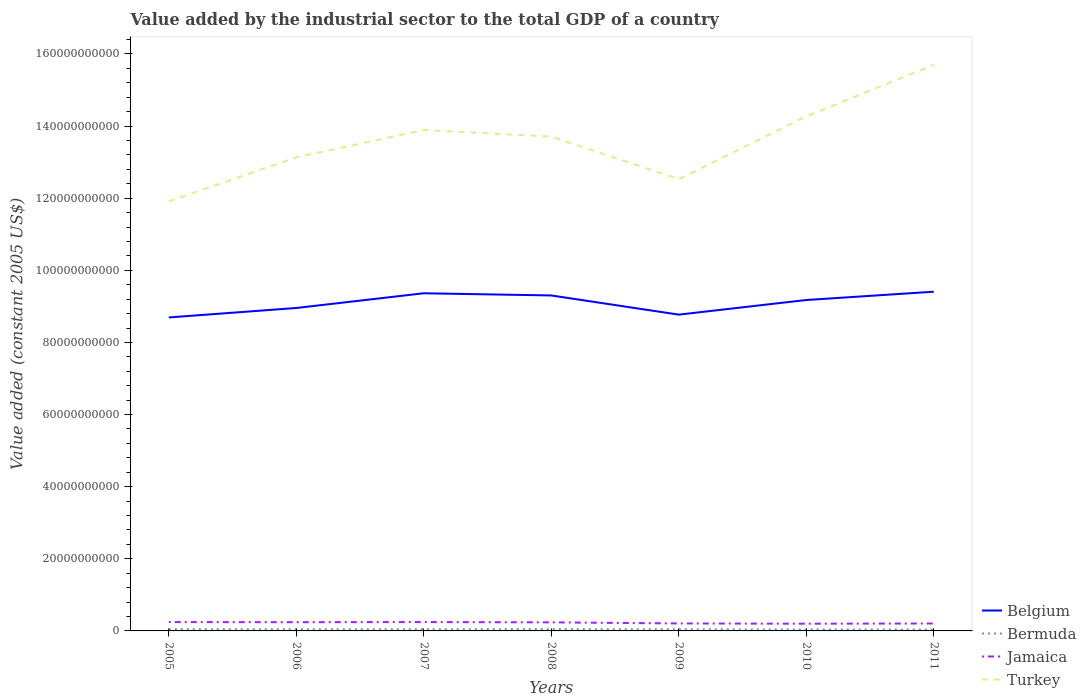How many different coloured lines are there?
Offer a terse response. 4. Does the line corresponding to Bermuda intersect with the line corresponding to Turkey?
Offer a very short reply. No. Across all years, what is the maximum value added by the industrial sector in Belgium?
Your answer should be very brief. 8.69e+1. In which year was the value added by the industrial sector in Turkey maximum?
Your answer should be very brief. 2005. What is the total value added by the industrial sector in Jamaica in the graph?
Your response must be concise. 4.50e+08. What is the difference between the highest and the second highest value added by the industrial sector in Belgium?
Ensure brevity in your answer.  7.14e+09. What is the difference between the highest and the lowest value added by the industrial sector in Jamaica?
Keep it short and to the point. 4. How many lines are there?
Give a very brief answer. 4. How many years are there in the graph?
Keep it short and to the point. 7. What is the difference between two consecutive major ticks on the Y-axis?
Make the answer very short. 2.00e+1. Does the graph contain grids?
Give a very brief answer. No. Where does the legend appear in the graph?
Your answer should be compact. Bottom right. How are the legend labels stacked?
Your response must be concise. Vertical. What is the title of the graph?
Provide a succinct answer. Value added by the industrial sector to the total GDP of a country. What is the label or title of the Y-axis?
Your answer should be compact. Value added (constant 2005 US$). What is the Value added (constant 2005 US$) in Belgium in 2005?
Offer a very short reply. 8.69e+1. What is the Value added (constant 2005 US$) of Bermuda in 2005?
Offer a terse response. 4.84e+08. What is the Value added (constant 2005 US$) of Jamaica in 2005?
Make the answer very short. 2.45e+09. What is the Value added (constant 2005 US$) in Turkey in 2005?
Ensure brevity in your answer.  1.19e+11. What is the Value added (constant 2005 US$) in Belgium in 2006?
Offer a very short reply. 8.96e+1. What is the Value added (constant 2005 US$) of Bermuda in 2006?
Give a very brief answer. 4.71e+08. What is the Value added (constant 2005 US$) in Jamaica in 2006?
Your response must be concise. 2.42e+09. What is the Value added (constant 2005 US$) in Turkey in 2006?
Make the answer very short. 1.31e+11. What is the Value added (constant 2005 US$) in Belgium in 2007?
Keep it short and to the point. 9.36e+1. What is the Value added (constant 2005 US$) of Bermuda in 2007?
Give a very brief answer. 4.71e+08. What is the Value added (constant 2005 US$) in Jamaica in 2007?
Make the answer very short. 2.46e+09. What is the Value added (constant 2005 US$) in Turkey in 2007?
Your response must be concise. 1.39e+11. What is the Value added (constant 2005 US$) of Belgium in 2008?
Keep it short and to the point. 9.30e+1. What is the Value added (constant 2005 US$) of Bermuda in 2008?
Offer a very short reply. 4.96e+08. What is the Value added (constant 2005 US$) in Jamaica in 2008?
Keep it short and to the point. 2.38e+09. What is the Value added (constant 2005 US$) of Turkey in 2008?
Your answer should be compact. 1.37e+11. What is the Value added (constant 2005 US$) of Belgium in 2009?
Your response must be concise. 8.77e+1. What is the Value added (constant 2005 US$) of Bermuda in 2009?
Offer a terse response. 4.49e+08. What is the Value added (constant 2005 US$) in Jamaica in 2009?
Your response must be concise. 2.07e+09. What is the Value added (constant 2005 US$) in Turkey in 2009?
Provide a succinct answer. 1.25e+11. What is the Value added (constant 2005 US$) of Belgium in 2010?
Make the answer very short. 9.18e+1. What is the Value added (constant 2005 US$) in Bermuda in 2010?
Keep it short and to the point. 3.98e+08. What is the Value added (constant 2005 US$) of Jamaica in 2010?
Offer a terse response. 2.00e+09. What is the Value added (constant 2005 US$) in Turkey in 2010?
Your answer should be compact. 1.43e+11. What is the Value added (constant 2005 US$) in Belgium in 2011?
Your answer should be compact. 9.41e+1. What is the Value added (constant 2005 US$) of Bermuda in 2011?
Provide a short and direct response. 3.90e+08. What is the Value added (constant 2005 US$) in Jamaica in 2011?
Offer a terse response. 2.06e+09. What is the Value added (constant 2005 US$) of Turkey in 2011?
Make the answer very short. 1.57e+11. Across all years, what is the maximum Value added (constant 2005 US$) of Belgium?
Make the answer very short. 9.41e+1. Across all years, what is the maximum Value added (constant 2005 US$) in Bermuda?
Provide a succinct answer. 4.96e+08. Across all years, what is the maximum Value added (constant 2005 US$) in Jamaica?
Give a very brief answer. 2.46e+09. Across all years, what is the maximum Value added (constant 2005 US$) of Turkey?
Provide a succinct answer. 1.57e+11. Across all years, what is the minimum Value added (constant 2005 US$) of Belgium?
Provide a succinct answer. 8.69e+1. Across all years, what is the minimum Value added (constant 2005 US$) of Bermuda?
Ensure brevity in your answer.  3.90e+08. Across all years, what is the minimum Value added (constant 2005 US$) in Jamaica?
Give a very brief answer. 2.00e+09. Across all years, what is the minimum Value added (constant 2005 US$) in Turkey?
Give a very brief answer. 1.19e+11. What is the total Value added (constant 2005 US$) in Belgium in the graph?
Offer a terse response. 6.37e+11. What is the total Value added (constant 2005 US$) in Bermuda in the graph?
Make the answer very short. 3.16e+09. What is the total Value added (constant 2005 US$) in Jamaica in the graph?
Your answer should be compact. 1.59e+1. What is the total Value added (constant 2005 US$) in Turkey in the graph?
Your response must be concise. 9.51e+11. What is the difference between the Value added (constant 2005 US$) in Belgium in 2005 and that in 2006?
Ensure brevity in your answer.  -2.62e+09. What is the difference between the Value added (constant 2005 US$) of Bermuda in 2005 and that in 2006?
Provide a short and direct response. 1.34e+07. What is the difference between the Value added (constant 2005 US$) in Jamaica in 2005 and that in 2006?
Ensure brevity in your answer.  3.22e+07. What is the difference between the Value added (constant 2005 US$) in Turkey in 2005 and that in 2006?
Offer a terse response. -1.22e+1. What is the difference between the Value added (constant 2005 US$) of Belgium in 2005 and that in 2007?
Make the answer very short. -6.70e+09. What is the difference between the Value added (constant 2005 US$) in Bermuda in 2005 and that in 2007?
Make the answer very short. 1.31e+07. What is the difference between the Value added (constant 2005 US$) in Jamaica in 2005 and that in 2007?
Give a very brief answer. -4.26e+06. What is the difference between the Value added (constant 2005 US$) in Turkey in 2005 and that in 2007?
Keep it short and to the point. -1.98e+1. What is the difference between the Value added (constant 2005 US$) in Belgium in 2005 and that in 2008?
Your answer should be compact. -6.09e+09. What is the difference between the Value added (constant 2005 US$) in Bermuda in 2005 and that in 2008?
Offer a terse response. -1.13e+07. What is the difference between the Value added (constant 2005 US$) of Jamaica in 2005 and that in 2008?
Make the answer very short. 7.34e+07. What is the difference between the Value added (constant 2005 US$) of Turkey in 2005 and that in 2008?
Give a very brief answer. -1.80e+1. What is the difference between the Value added (constant 2005 US$) in Belgium in 2005 and that in 2009?
Provide a short and direct response. -7.76e+08. What is the difference between the Value added (constant 2005 US$) in Bermuda in 2005 and that in 2009?
Provide a short and direct response. 3.53e+07. What is the difference between the Value added (constant 2005 US$) of Jamaica in 2005 and that in 2009?
Offer a terse response. 3.81e+08. What is the difference between the Value added (constant 2005 US$) of Turkey in 2005 and that in 2009?
Make the answer very short. -6.16e+09. What is the difference between the Value added (constant 2005 US$) of Belgium in 2005 and that in 2010?
Your response must be concise. -4.83e+09. What is the difference between the Value added (constant 2005 US$) of Bermuda in 2005 and that in 2010?
Offer a terse response. 8.69e+07. What is the difference between the Value added (constant 2005 US$) of Jamaica in 2005 and that in 2010?
Your answer should be compact. 4.50e+08. What is the difference between the Value added (constant 2005 US$) in Turkey in 2005 and that in 2010?
Offer a terse response. -2.35e+1. What is the difference between the Value added (constant 2005 US$) of Belgium in 2005 and that in 2011?
Your response must be concise. -7.14e+09. What is the difference between the Value added (constant 2005 US$) in Bermuda in 2005 and that in 2011?
Provide a short and direct response. 9.45e+07. What is the difference between the Value added (constant 2005 US$) in Jamaica in 2005 and that in 2011?
Give a very brief answer. 3.92e+08. What is the difference between the Value added (constant 2005 US$) in Turkey in 2005 and that in 2011?
Give a very brief answer. -3.79e+1. What is the difference between the Value added (constant 2005 US$) in Belgium in 2006 and that in 2007?
Your response must be concise. -4.08e+09. What is the difference between the Value added (constant 2005 US$) in Bermuda in 2006 and that in 2007?
Give a very brief answer. -2.84e+05. What is the difference between the Value added (constant 2005 US$) in Jamaica in 2006 and that in 2007?
Offer a terse response. -3.65e+07. What is the difference between the Value added (constant 2005 US$) of Turkey in 2006 and that in 2007?
Your response must be concise. -7.57e+09. What is the difference between the Value added (constant 2005 US$) of Belgium in 2006 and that in 2008?
Give a very brief answer. -3.47e+09. What is the difference between the Value added (constant 2005 US$) in Bermuda in 2006 and that in 2008?
Ensure brevity in your answer.  -2.48e+07. What is the difference between the Value added (constant 2005 US$) in Jamaica in 2006 and that in 2008?
Make the answer very short. 4.12e+07. What is the difference between the Value added (constant 2005 US$) in Turkey in 2006 and that in 2008?
Provide a short and direct response. -5.76e+09. What is the difference between the Value added (constant 2005 US$) in Belgium in 2006 and that in 2009?
Provide a succinct answer. 1.84e+09. What is the difference between the Value added (constant 2005 US$) of Bermuda in 2006 and that in 2009?
Your answer should be compact. 2.19e+07. What is the difference between the Value added (constant 2005 US$) in Jamaica in 2006 and that in 2009?
Offer a terse response. 3.49e+08. What is the difference between the Value added (constant 2005 US$) of Turkey in 2006 and that in 2009?
Make the answer very short. 6.04e+09. What is the difference between the Value added (constant 2005 US$) of Belgium in 2006 and that in 2010?
Give a very brief answer. -2.21e+09. What is the difference between the Value added (constant 2005 US$) in Bermuda in 2006 and that in 2010?
Keep it short and to the point. 7.35e+07. What is the difference between the Value added (constant 2005 US$) of Jamaica in 2006 and that in 2010?
Give a very brief answer. 4.17e+08. What is the difference between the Value added (constant 2005 US$) in Turkey in 2006 and that in 2010?
Give a very brief answer. -1.14e+1. What is the difference between the Value added (constant 2005 US$) of Belgium in 2006 and that in 2011?
Provide a succinct answer. -4.51e+09. What is the difference between the Value added (constant 2005 US$) in Bermuda in 2006 and that in 2011?
Make the answer very short. 8.11e+07. What is the difference between the Value added (constant 2005 US$) of Jamaica in 2006 and that in 2011?
Keep it short and to the point. 3.59e+08. What is the difference between the Value added (constant 2005 US$) in Turkey in 2006 and that in 2011?
Ensure brevity in your answer.  -2.57e+1. What is the difference between the Value added (constant 2005 US$) of Belgium in 2007 and that in 2008?
Your answer should be compact. 6.09e+08. What is the difference between the Value added (constant 2005 US$) of Bermuda in 2007 and that in 2008?
Your response must be concise. -2.45e+07. What is the difference between the Value added (constant 2005 US$) in Jamaica in 2007 and that in 2008?
Keep it short and to the point. 7.76e+07. What is the difference between the Value added (constant 2005 US$) of Turkey in 2007 and that in 2008?
Make the answer very short. 1.81e+09. What is the difference between the Value added (constant 2005 US$) of Belgium in 2007 and that in 2009?
Ensure brevity in your answer.  5.93e+09. What is the difference between the Value added (constant 2005 US$) of Bermuda in 2007 and that in 2009?
Give a very brief answer. 2.22e+07. What is the difference between the Value added (constant 2005 US$) in Jamaica in 2007 and that in 2009?
Ensure brevity in your answer.  3.86e+08. What is the difference between the Value added (constant 2005 US$) in Turkey in 2007 and that in 2009?
Ensure brevity in your answer.  1.36e+1. What is the difference between the Value added (constant 2005 US$) of Belgium in 2007 and that in 2010?
Your answer should be compact. 1.87e+09. What is the difference between the Value added (constant 2005 US$) in Bermuda in 2007 and that in 2010?
Offer a very short reply. 7.38e+07. What is the difference between the Value added (constant 2005 US$) in Jamaica in 2007 and that in 2010?
Your answer should be compact. 4.54e+08. What is the difference between the Value added (constant 2005 US$) of Turkey in 2007 and that in 2010?
Give a very brief answer. -3.78e+09. What is the difference between the Value added (constant 2005 US$) in Belgium in 2007 and that in 2011?
Give a very brief answer. -4.31e+08. What is the difference between the Value added (constant 2005 US$) in Bermuda in 2007 and that in 2011?
Offer a very short reply. 8.14e+07. What is the difference between the Value added (constant 2005 US$) in Jamaica in 2007 and that in 2011?
Give a very brief answer. 3.96e+08. What is the difference between the Value added (constant 2005 US$) in Turkey in 2007 and that in 2011?
Your response must be concise. -1.81e+1. What is the difference between the Value added (constant 2005 US$) in Belgium in 2008 and that in 2009?
Your response must be concise. 5.32e+09. What is the difference between the Value added (constant 2005 US$) of Bermuda in 2008 and that in 2009?
Ensure brevity in your answer.  4.66e+07. What is the difference between the Value added (constant 2005 US$) in Jamaica in 2008 and that in 2009?
Ensure brevity in your answer.  3.08e+08. What is the difference between the Value added (constant 2005 US$) in Turkey in 2008 and that in 2009?
Keep it short and to the point. 1.18e+1. What is the difference between the Value added (constant 2005 US$) of Belgium in 2008 and that in 2010?
Your answer should be compact. 1.26e+09. What is the difference between the Value added (constant 2005 US$) in Bermuda in 2008 and that in 2010?
Your response must be concise. 9.82e+07. What is the difference between the Value added (constant 2005 US$) of Jamaica in 2008 and that in 2010?
Your answer should be compact. 3.76e+08. What is the difference between the Value added (constant 2005 US$) in Turkey in 2008 and that in 2010?
Your answer should be compact. -5.60e+09. What is the difference between the Value added (constant 2005 US$) of Belgium in 2008 and that in 2011?
Offer a terse response. -1.04e+09. What is the difference between the Value added (constant 2005 US$) in Bermuda in 2008 and that in 2011?
Provide a succinct answer. 1.06e+08. What is the difference between the Value added (constant 2005 US$) of Jamaica in 2008 and that in 2011?
Offer a terse response. 3.18e+08. What is the difference between the Value added (constant 2005 US$) of Turkey in 2008 and that in 2011?
Provide a short and direct response. -1.99e+1. What is the difference between the Value added (constant 2005 US$) in Belgium in 2009 and that in 2010?
Your answer should be compact. -4.05e+09. What is the difference between the Value added (constant 2005 US$) of Bermuda in 2009 and that in 2010?
Your answer should be very brief. 5.16e+07. What is the difference between the Value added (constant 2005 US$) of Jamaica in 2009 and that in 2010?
Provide a succinct answer. 6.83e+07. What is the difference between the Value added (constant 2005 US$) of Turkey in 2009 and that in 2010?
Offer a very short reply. -1.74e+1. What is the difference between the Value added (constant 2005 US$) of Belgium in 2009 and that in 2011?
Keep it short and to the point. -6.36e+09. What is the difference between the Value added (constant 2005 US$) in Bermuda in 2009 and that in 2011?
Offer a very short reply. 5.92e+07. What is the difference between the Value added (constant 2005 US$) of Jamaica in 2009 and that in 2011?
Provide a short and direct response. 1.03e+07. What is the difference between the Value added (constant 2005 US$) of Turkey in 2009 and that in 2011?
Give a very brief answer. -3.17e+1. What is the difference between the Value added (constant 2005 US$) of Belgium in 2010 and that in 2011?
Your answer should be very brief. -2.30e+09. What is the difference between the Value added (constant 2005 US$) of Bermuda in 2010 and that in 2011?
Your answer should be very brief. 7.61e+06. What is the difference between the Value added (constant 2005 US$) of Jamaica in 2010 and that in 2011?
Keep it short and to the point. -5.79e+07. What is the difference between the Value added (constant 2005 US$) in Turkey in 2010 and that in 2011?
Offer a terse response. -1.43e+1. What is the difference between the Value added (constant 2005 US$) in Belgium in 2005 and the Value added (constant 2005 US$) in Bermuda in 2006?
Provide a succinct answer. 8.65e+1. What is the difference between the Value added (constant 2005 US$) of Belgium in 2005 and the Value added (constant 2005 US$) of Jamaica in 2006?
Your response must be concise. 8.45e+1. What is the difference between the Value added (constant 2005 US$) of Belgium in 2005 and the Value added (constant 2005 US$) of Turkey in 2006?
Offer a very short reply. -4.44e+1. What is the difference between the Value added (constant 2005 US$) in Bermuda in 2005 and the Value added (constant 2005 US$) in Jamaica in 2006?
Offer a terse response. -1.94e+09. What is the difference between the Value added (constant 2005 US$) of Bermuda in 2005 and the Value added (constant 2005 US$) of Turkey in 2006?
Ensure brevity in your answer.  -1.31e+11. What is the difference between the Value added (constant 2005 US$) of Jamaica in 2005 and the Value added (constant 2005 US$) of Turkey in 2006?
Ensure brevity in your answer.  -1.29e+11. What is the difference between the Value added (constant 2005 US$) of Belgium in 2005 and the Value added (constant 2005 US$) of Bermuda in 2007?
Offer a terse response. 8.65e+1. What is the difference between the Value added (constant 2005 US$) of Belgium in 2005 and the Value added (constant 2005 US$) of Jamaica in 2007?
Provide a succinct answer. 8.45e+1. What is the difference between the Value added (constant 2005 US$) in Belgium in 2005 and the Value added (constant 2005 US$) in Turkey in 2007?
Offer a very short reply. -5.20e+1. What is the difference between the Value added (constant 2005 US$) of Bermuda in 2005 and the Value added (constant 2005 US$) of Jamaica in 2007?
Offer a very short reply. -1.97e+09. What is the difference between the Value added (constant 2005 US$) of Bermuda in 2005 and the Value added (constant 2005 US$) of Turkey in 2007?
Your answer should be very brief. -1.38e+11. What is the difference between the Value added (constant 2005 US$) in Jamaica in 2005 and the Value added (constant 2005 US$) in Turkey in 2007?
Offer a terse response. -1.36e+11. What is the difference between the Value added (constant 2005 US$) of Belgium in 2005 and the Value added (constant 2005 US$) of Bermuda in 2008?
Give a very brief answer. 8.64e+1. What is the difference between the Value added (constant 2005 US$) in Belgium in 2005 and the Value added (constant 2005 US$) in Jamaica in 2008?
Provide a succinct answer. 8.46e+1. What is the difference between the Value added (constant 2005 US$) in Belgium in 2005 and the Value added (constant 2005 US$) in Turkey in 2008?
Offer a terse response. -5.02e+1. What is the difference between the Value added (constant 2005 US$) of Bermuda in 2005 and the Value added (constant 2005 US$) of Jamaica in 2008?
Your response must be concise. -1.90e+09. What is the difference between the Value added (constant 2005 US$) in Bermuda in 2005 and the Value added (constant 2005 US$) in Turkey in 2008?
Give a very brief answer. -1.37e+11. What is the difference between the Value added (constant 2005 US$) in Jamaica in 2005 and the Value added (constant 2005 US$) in Turkey in 2008?
Make the answer very short. -1.35e+11. What is the difference between the Value added (constant 2005 US$) in Belgium in 2005 and the Value added (constant 2005 US$) in Bermuda in 2009?
Your response must be concise. 8.65e+1. What is the difference between the Value added (constant 2005 US$) in Belgium in 2005 and the Value added (constant 2005 US$) in Jamaica in 2009?
Your answer should be very brief. 8.49e+1. What is the difference between the Value added (constant 2005 US$) of Belgium in 2005 and the Value added (constant 2005 US$) of Turkey in 2009?
Ensure brevity in your answer.  -3.84e+1. What is the difference between the Value added (constant 2005 US$) in Bermuda in 2005 and the Value added (constant 2005 US$) in Jamaica in 2009?
Keep it short and to the point. -1.59e+09. What is the difference between the Value added (constant 2005 US$) in Bermuda in 2005 and the Value added (constant 2005 US$) in Turkey in 2009?
Your answer should be compact. -1.25e+11. What is the difference between the Value added (constant 2005 US$) of Jamaica in 2005 and the Value added (constant 2005 US$) of Turkey in 2009?
Offer a very short reply. -1.23e+11. What is the difference between the Value added (constant 2005 US$) of Belgium in 2005 and the Value added (constant 2005 US$) of Bermuda in 2010?
Your answer should be very brief. 8.65e+1. What is the difference between the Value added (constant 2005 US$) in Belgium in 2005 and the Value added (constant 2005 US$) in Jamaica in 2010?
Keep it short and to the point. 8.49e+1. What is the difference between the Value added (constant 2005 US$) of Belgium in 2005 and the Value added (constant 2005 US$) of Turkey in 2010?
Provide a succinct answer. -5.57e+1. What is the difference between the Value added (constant 2005 US$) in Bermuda in 2005 and the Value added (constant 2005 US$) in Jamaica in 2010?
Offer a terse response. -1.52e+09. What is the difference between the Value added (constant 2005 US$) in Bermuda in 2005 and the Value added (constant 2005 US$) in Turkey in 2010?
Your response must be concise. -1.42e+11. What is the difference between the Value added (constant 2005 US$) of Jamaica in 2005 and the Value added (constant 2005 US$) of Turkey in 2010?
Provide a short and direct response. -1.40e+11. What is the difference between the Value added (constant 2005 US$) in Belgium in 2005 and the Value added (constant 2005 US$) in Bermuda in 2011?
Your answer should be compact. 8.65e+1. What is the difference between the Value added (constant 2005 US$) of Belgium in 2005 and the Value added (constant 2005 US$) of Jamaica in 2011?
Ensure brevity in your answer.  8.49e+1. What is the difference between the Value added (constant 2005 US$) of Belgium in 2005 and the Value added (constant 2005 US$) of Turkey in 2011?
Offer a very short reply. -7.01e+1. What is the difference between the Value added (constant 2005 US$) of Bermuda in 2005 and the Value added (constant 2005 US$) of Jamaica in 2011?
Your answer should be very brief. -1.58e+09. What is the difference between the Value added (constant 2005 US$) in Bermuda in 2005 and the Value added (constant 2005 US$) in Turkey in 2011?
Provide a succinct answer. -1.57e+11. What is the difference between the Value added (constant 2005 US$) of Jamaica in 2005 and the Value added (constant 2005 US$) of Turkey in 2011?
Keep it short and to the point. -1.55e+11. What is the difference between the Value added (constant 2005 US$) of Belgium in 2006 and the Value added (constant 2005 US$) of Bermuda in 2007?
Ensure brevity in your answer.  8.91e+1. What is the difference between the Value added (constant 2005 US$) of Belgium in 2006 and the Value added (constant 2005 US$) of Jamaica in 2007?
Provide a succinct answer. 8.71e+1. What is the difference between the Value added (constant 2005 US$) in Belgium in 2006 and the Value added (constant 2005 US$) in Turkey in 2007?
Offer a terse response. -4.93e+1. What is the difference between the Value added (constant 2005 US$) in Bermuda in 2006 and the Value added (constant 2005 US$) in Jamaica in 2007?
Ensure brevity in your answer.  -1.99e+09. What is the difference between the Value added (constant 2005 US$) in Bermuda in 2006 and the Value added (constant 2005 US$) in Turkey in 2007?
Keep it short and to the point. -1.38e+11. What is the difference between the Value added (constant 2005 US$) of Jamaica in 2006 and the Value added (constant 2005 US$) of Turkey in 2007?
Your answer should be compact. -1.36e+11. What is the difference between the Value added (constant 2005 US$) in Belgium in 2006 and the Value added (constant 2005 US$) in Bermuda in 2008?
Your response must be concise. 8.91e+1. What is the difference between the Value added (constant 2005 US$) in Belgium in 2006 and the Value added (constant 2005 US$) in Jamaica in 2008?
Your answer should be compact. 8.72e+1. What is the difference between the Value added (constant 2005 US$) in Belgium in 2006 and the Value added (constant 2005 US$) in Turkey in 2008?
Provide a succinct answer. -4.75e+1. What is the difference between the Value added (constant 2005 US$) in Bermuda in 2006 and the Value added (constant 2005 US$) in Jamaica in 2008?
Your response must be concise. -1.91e+09. What is the difference between the Value added (constant 2005 US$) of Bermuda in 2006 and the Value added (constant 2005 US$) of Turkey in 2008?
Give a very brief answer. -1.37e+11. What is the difference between the Value added (constant 2005 US$) of Jamaica in 2006 and the Value added (constant 2005 US$) of Turkey in 2008?
Offer a terse response. -1.35e+11. What is the difference between the Value added (constant 2005 US$) of Belgium in 2006 and the Value added (constant 2005 US$) of Bermuda in 2009?
Your answer should be compact. 8.91e+1. What is the difference between the Value added (constant 2005 US$) in Belgium in 2006 and the Value added (constant 2005 US$) in Jamaica in 2009?
Your response must be concise. 8.75e+1. What is the difference between the Value added (constant 2005 US$) of Belgium in 2006 and the Value added (constant 2005 US$) of Turkey in 2009?
Provide a succinct answer. -3.57e+1. What is the difference between the Value added (constant 2005 US$) of Bermuda in 2006 and the Value added (constant 2005 US$) of Jamaica in 2009?
Your answer should be compact. -1.60e+09. What is the difference between the Value added (constant 2005 US$) in Bermuda in 2006 and the Value added (constant 2005 US$) in Turkey in 2009?
Provide a succinct answer. -1.25e+11. What is the difference between the Value added (constant 2005 US$) of Jamaica in 2006 and the Value added (constant 2005 US$) of Turkey in 2009?
Your answer should be compact. -1.23e+11. What is the difference between the Value added (constant 2005 US$) in Belgium in 2006 and the Value added (constant 2005 US$) in Bermuda in 2010?
Your response must be concise. 8.92e+1. What is the difference between the Value added (constant 2005 US$) in Belgium in 2006 and the Value added (constant 2005 US$) in Jamaica in 2010?
Ensure brevity in your answer.  8.76e+1. What is the difference between the Value added (constant 2005 US$) of Belgium in 2006 and the Value added (constant 2005 US$) of Turkey in 2010?
Provide a succinct answer. -5.31e+1. What is the difference between the Value added (constant 2005 US$) of Bermuda in 2006 and the Value added (constant 2005 US$) of Jamaica in 2010?
Ensure brevity in your answer.  -1.53e+09. What is the difference between the Value added (constant 2005 US$) of Bermuda in 2006 and the Value added (constant 2005 US$) of Turkey in 2010?
Provide a succinct answer. -1.42e+11. What is the difference between the Value added (constant 2005 US$) in Jamaica in 2006 and the Value added (constant 2005 US$) in Turkey in 2010?
Offer a terse response. -1.40e+11. What is the difference between the Value added (constant 2005 US$) in Belgium in 2006 and the Value added (constant 2005 US$) in Bermuda in 2011?
Give a very brief answer. 8.92e+1. What is the difference between the Value added (constant 2005 US$) of Belgium in 2006 and the Value added (constant 2005 US$) of Jamaica in 2011?
Your answer should be very brief. 8.75e+1. What is the difference between the Value added (constant 2005 US$) in Belgium in 2006 and the Value added (constant 2005 US$) in Turkey in 2011?
Give a very brief answer. -6.74e+1. What is the difference between the Value added (constant 2005 US$) of Bermuda in 2006 and the Value added (constant 2005 US$) of Jamaica in 2011?
Provide a succinct answer. -1.59e+09. What is the difference between the Value added (constant 2005 US$) in Bermuda in 2006 and the Value added (constant 2005 US$) in Turkey in 2011?
Give a very brief answer. -1.57e+11. What is the difference between the Value added (constant 2005 US$) of Jamaica in 2006 and the Value added (constant 2005 US$) of Turkey in 2011?
Provide a short and direct response. -1.55e+11. What is the difference between the Value added (constant 2005 US$) of Belgium in 2007 and the Value added (constant 2005 US$) of Bermuda in 2008?
Offer a very short reply. 9.31e+1. What is the difference between the Value added (constant 2005 US$) in Belgium in 2007 and the Value added (constant 2005 US$) in Jamaica in 2008?
Keep it short and to the point. 9.13e+1. What is the difference between the Value added (constant 2005 US$) in Belgium in 2007 and the Value added (constant 2005 US$) in Turkey in 2008?
Provide a succinct answer. -4.34e+1. What is the difference between the Value added (constant 2005 US$) of Bermuda in 2007 and the Value added (constant 2005 US$) of Jamaica in 2008?
Offer a terse response. -1.91e+09. What is the difference between the Value added (constant 2005 US$) in Bermuda in 2007 and the Value added (constant 2005 US$) in Turkey in 2008?
Provide a succinct answer. -1.37e+11. What is the difference between the Value added (constant 2005 US$) of Jamaica in 2007 and the Value added (constant 2005 US$) of Turkey in 2008?
Offer a very short reply. -1.35e+11. What is the difference between the Value added (constant 2005 US$) of Belgium in 2007 and the Value added (constant 2005 US$) of Bermuda in 2009?
Your answer should be compact. 9.32e+1. What is the difference between the Value added (constant 2005 US$) in Belgium in 2007 and the Value added (constant 2005 US$) in Jamaica in 2009?
Make the answer very short. 9.16e+1. What is the difference between the Value added (constant 2005 US$) of Belgium in 2007 and the Value added (constant 2005 US$) of Turkey in 2009?
Provide a succinct answer. -3.17e+1. What is the difference between the Value added (constant 2005 US$) in Bermuda in 2007 and the Value added (constant 2005 US$) in Jamaica in 2009?
Provide a succinct answer. -1.60e+09. What is the difference between the Value added (constant 2005 US$) of Bermuda in 2007 and the Value added (constant 2005 US$) of Turkey in 2009?
Make the answer very short. -1.25e+11. What is the difference between the Value added (constant 2005 US$) of Jamaica in 2007 and the Value added (constant 2005 US$) of Turkey in 2009?
Your response must be concise. -1.23e+11. What is the difference between the Value added (constant 2005 US$) in Belgium in 2007 and the Value added (constant 2005 US$) in Bermuda in 2010?
Offer a terse response. 9.32e+1. What is the difference between the Value added (constant 2005 US$) in Belgium in 2007 and the Value added (constant 2005 US$) in Jamaica in 2010?
Provide a succinct answer. 9.16e+1. What is the difference between the Value added (constant 2005 US$) in Belgium in 2007 and the Value added (constant 2005 US$) in Turkey in 2010?
Your answer should be very brief. -4.90e+1. What is the difference between the Value added (constant 2005 US$) in Bermuda in 2007 and the Value added (constant 2005 US$) in Jamaica in 2010?
Give a very brief answer. -1.53e+09. What is the difference between the Value added (constant 2005 US$) of Bermuda in 2007 and the Value added (constant 2005 US$) of Turkey in 2010?
Provide a succinct answer. -1.42e+11. What is the difference between the Value added (constant 2005 US$) of Jamaica in 2007 and the Value added (constant 2005 US$) of Turkey in 2010?
Keep it short and to the point. -1.40e+11. What is the difference between the Value added (constant 2005 US$) of Belgium in 2007 and the Value added (constant 2005 US$) of Bermuda in 2011?
Ensure brevity in your answer.  9.33e+1. What is the difference between the Value added (constant 2005 US$) in Belgium in 2007 and the Value added (constant 2005 US$) in Jamaica in 2011?
Offer a very short reply. 9.16e+1. What is the difference between the Value added (constant 2005 US$) in Belgium in 2007 and the Value added (constant 2005 US$) in Turkey in 2011?
Make the answer very short. -6.34e+1. What is the difference between the Value added (constant 2005 US$) of Bermuda in 2007 and the Value added (constant 2005 US$) of Jamaica in 2011?
Give a very brief answer. -1.59e+09. What is the difference between the Value added (constant 2005 US$) in Bermuda in 2007 and the Value added (constant 2005 US$) in Turkey in 2011?
Your answer should be very brief. -1.57e+11. What is the difference between the Value added (constant 2005 US$) in Jamaica in 2007 and the Value added (constant 2005 US$) in Turkey in 2011?
Provide a short and direct response. -1.55e+11. What is the difference between the Value added (constant 2005 US$) of Belgium in 2008 and the Value added (constant 2005 US$) of Bermuda in 2009?
Make the answer very short. 9.26e+1. What is the difference between the Value added (constant 2005 US$) in Belgium in 2008 and the Value added (constant 2005 US$) in Jamaica in 2009?
Give a very brief answer. 9.10e+1. What is the difference between the Value added (constant 2005 US$) in Belgium in 2008 and the Value added (constant 2005 US$) in Turkey in 2009?
Offer a very short reply. -3.23e+1. What is the difference between the Value added (constant 2005 US$) in Bermuda in 2008 and the Value added (constant 2005 US$) in Jamaica in 2009?
Provide a succinct answer. -1.58e+09. What is the difference between the Value added (constant 2005 US$) of Bermuda in 2008 and the Value added (constant 2005 US$) of Turkey in 2009?
Offer a very short reply. -1.25e+11. What is the difference between the Value added (constant 2005 US$) in Jamaica in 2008 and the Value added (constant 2005 US$) in Turkey in 2009?
Ensure brevity in your answer.  -1.23e+11. What is the difference between the Value added (constant 2005 US$) of Belgium in 2008 and the Value added (constant 2005 US$) of Bermuda in 2010?
Provide a short and direct response. 9.26e+1. What is the difference between the Value added (constant 2005 US$) of Belgium in 2008 and the Value added (constant 2005 US$) of Jamaica in 2010?
Your answer should be compact. 9.10e+1. What is the difference between the Value added (constant 2005 US$) in Belgium in 2008 and the Value added (constant 2005 US$) in Turkey in 2010?
Offer a very short reply. -4.97e+1. What is the difference between the Value added (constant 2005 US$) in Bermuda in 2008 and the Value added (constant 2005 US$) in Jamaica in 2010?
Your response must be concise. -1.51e+09. What is the difference between the Value added (constant 2005 US$) of Bermuda in 2008 and the Value added (constant 2005 US$) of Turkey in 2010?
Offer a terse response. -1.42e+11. What is the difference between the Value added (constant 2005 US$) in Jamaica in 2008 and the Value added (constant 2005 US$) in Turkey in 2010?
Offer a terse response. -1.40e+11. What is the difference between the Value added (constant 2005 US$) in Belgium in 2008 and the Value added (constant 2005 US$) in Bermuda in 2011?
Keep it short and to the point. 9.26e+1. What is the difference between the Value added (constant 2005 US$) of Belgium in 2008 and the Value added (constant 2005 US$) of Jamaica in 2011?
Provide a succinct answer. 9.10e+1. What is the difference between the Value added (constant 2005 US$) of Belgium in 2008 and the Value added (constant 2005 US$) of Turkey in 2011?
Offer a terse response. -6.40e+1. What is the difference between the Value added (constant 2005 US$) in Bermuda in 2008 and the Value added (constant 2005 US$) in Jamaica in 2011?
Give a very brief answer. -1.57e+09. What is the difference between the Value added (constant 2005 US$) of Bermuda in 2008 and the Value added (constant 2005 US$) of Turkey in 2011?
Provide a succinct answer. -1.56e+11. What is the difference between the Value added (constant 2005 US$) of Jamaica in 2008 and the Value added (constant 2005 US$) of Turkey in 2011?
Offer a terse response. -1.55e+11. What is the difference between the Value added (constant 2005 US$) in Belgium in 2009 and the Value added (constant 2005 US$) in Bermuda in 2010?
Offer a very short reply. 8.73e+1. What is the difference between the Value added (constant 2005 US$) of Belgium in 2009 and the Value added (constant 2005 US$) of Jamaica in 2010?
Keep it short and to the point. 8.57e+1. What is the difference between the Value added (constant 2005 US$) of Belgium in 2009 and the Value added (constant 2005 US$) of Turkey in 2010?
Provide a succinct answer. -5.50e+1. What is the difference between the Value added (constant 2005 US$) of Bermuda in 2009 and the Value added (constant 2005 US$) of Jamaica in 2010?
Your response must be concise. -1.56e+09. What is the difference between the Value added (constant 2005 US$) of Bermuda in 2009 and the Value added (constant 2005 US$) of Turkey in 2010?
Provide a short and direct response. -1.42e+11. What is the difference between the Value added (constant 2005 US$) of Jamaica in 2009 and the Value added (constant 2005 US$) of Turkey in 2010?
Ensure brevity in your answer.  -1.41e+11. What is the difference between the Value added (constant 2005 US$) in Belgium in 2009 and the Value added (constant 2005 US$) in Bermuda in 2011?
Make the answer very short. 8.73e+1. What is the difference between the Value added (constant 2005 US$) of Belgium in 2009 and the Value added (constant 2005 US$) of Jamaica in 2011?
Your response must be concise. 8.57e+1. What is the difference between the Value added (constant 2005 US$) of Belgium in 2009 and the Value added (constant 2005 US$) of Turkey in 2011?
Provide a short and direct response. -6.93e+1. What is the difference between the Value added (constant 2005 US$) of Bermuda in 2009 and the Value added (constant 2005 US$) of Jamaica in 2011?
Your answer should be compact. -1.61e+09. What is the difference between the Value added (constant 2005 US$) of Bermuda in 2009 and the Value added (constant 2005 US$) of Turkey in 2011?
Give a very brief answer. -1.57e+11. What is the difference between the Value added (constant 2005 US$) of Jamaica in 2009 and the Value added (constant 2005 US$) of Turkey in 2011?
Make the answer very short. -1.55e+11. What is the difference between the Value added (constant 2005 US$) in Belgium in 2010 and the Value added (constant 2005 US$) in Bermuda in 2011?
Your answer should be very brief. 9.14e+1. What is the difference between the Value added (constant 2005 US$) of Belgium in 2010 and the Value added (constant 2005 US$) of Jamaica in 2011?
Make the answer very short. 8.97e+1. What is the difference between the Value added (constant 2005 US$) in Belgium in 2010 and the Value added (constant 2005 US$) in Turkey in 2011?
Make the answer very short. -6.52e+1. What is the difference between the Value added (constant 2005 US$) of Bermuda in 2010 and the Value added (constant 2005 US$) of Jamaica in 2011?
Ensure brevity in your answer.  -1.66e+09. What is the difference between the Value added (constant 2005 US$) in Bermuda in 2010 and the Value added (constant 2005 US$) in Turkey in 2011?
Your response must be concise. -1.57e+11. What is the difference between the Value added (constant 2005 US$) in Jamaica in 2010 and the Value added (constant 2005 US$) in Turkey in 2011?
Provide a short and direct response. -1.55e+11. What is the average Value added (constant 2005 US$) in Belgium per year?
Keep it short and to the point. 9.10e+1. What is the average Value added (constant 2005 US$) in Bermuda per year?
Offer a very short reply. 4.51e+08. What is the average Value added (constant 2005 US$) of Jamaica per year?
Offer a terse response. 2.26e+09. What is the average Value added (constant 2005 US$) of Turkey per year?
Provide a short and direct response. 1.36e+11. In the year 2005, what is the difference between the Value added (constant 2005 US$) in Belgium and Value added (constant 2005 US$) in Bermuda?
Provide a short and direct response. 8.65e+1. In the year 2005, what is the difference between the Value added (constant 2005 US$) in Belgium and Value added (constant 2005 US$) in Jamaica?
Ensure brevity in your answer.  8.45e+1. In the year 2005, what is the difference between the Value added (constant 2005 US$) in Belgium and Value added (constant 2005 US$) in Turkey?
Keep it short and to the point. -3.22e+1. In the year 2005, what is the difference between the Value added (constant 2005 US$) in Bermuda and Value added (constant 2005 US$) in Jamaica?
Make the answer very short. -1.97e+09. In the year 2005, what is the difference between the Value added (constant 2005 US$) of Bermuda and Value added (constant 2005 US$) of Turkey?
Your answer should be very brief. -1.19e+11. In the year 2005, what is the difference between the Value added (constant 2005 US$) of Jamaica and Value added (constant 2005 US$) of Turkey?
Your answer should be very brief. -1.17e+11. In the year 2006, what is the difference between the Value added (constant 2005 US$) of Belgium and Value added (constant 2005 US$) of Bermuda?
Ensure brevity in your answer.  8.91e+1. In the year 2006, what is the difference between the Value added (constant 2005 US$) of Belgium and Value added (constant 2005 US$) of Jamaica?
Give a very brief answer. 8.71e+1. In the year 2006, what is the difference between the Value added (constant 2005 US$) of Belgium and Value added (constant 2005 US$) of Turkey?
Your response must be concise. -4.18e+1. In the year 2006, what is the difference between the Value added (constant 2005 US$) in Bermuda and Value added (constant 2005 US$) in Jamaica?
Ensure brevity in your answer.  -1.95e+09. In the year 2006, what is the difference between the Value added (constant 2005 US$) of Bermuda and Value added (constant 2005 US$) of Turkey?
Your answer should be very brief. -1.31e+11. In the year 2006, what is the difference between the Value added (constant 2005 US$) in Jamaica and Value added (constant 2005 US$) in Turkey?
Ensure brevity in your answer.  -1.29e+11. In the year 2007, what is the difference between the Value added (constant 2005 US$) in Belgium and Value added (constant 2005 US$) in Bermuda?
Provide a short and direct response. 9.32e+1. In the year 2007, what is the difference between the Value added (constant 2005 US$) in Belgium and Value added (constant 2005 US$) in Jamaica?
Keep it short and to the point. 9.12e+1. In the year 2007, what is the difference between the Value added (constant 2005 US$) in Belgium and Value added (constant 2005 US$) in Turkey?
Your response must be concise. -4.53e+1. In the year 2007, what is the difference between the Value added (constant 2005 US$) of Bermuda and Value added (constant 2005 US$) of Jamaica?
Provide a succinct answer. -1.99e+09. In the year 2007, what is the difference between the Value added (constant 2005 US$) of Bermuda and Value added (constant 2005 US$) of Turkey?
Your answer should be very brief. -1.38e+11. In the year 2007, what is the difference between the Value added (constant 2005 US$) in Jamaica and Value added (constant 2005 US$) in Turkey?
Your answer should be very brief. -1.36e+11. In the year 2008, what is the difference between the Value added (constant 2005 US$) of Belgium and Value added (constant 2005 US$) of Bermuda?
Your answer should be compact. 9.25e+1. In the year 2008, what is the difference between the Value added (constant 2005 US$) of Belgium and Value added (constant 2005 US$) of Jamaica?
Offer a very short reply. 9.07e+1. In the year 2008, what is the difference between the Value added (constant 2005 US$) in Belgium and Value added (constant 2005 US$) in Turkey?
Ensure brevity in your answer.  -4.41e+1. In the year 2008, what is the difference between the Value added (constant 2005 US$) of Bermuda and Value added (constant 2005 US$) of Jamaica?
Provide a succinct answer. -1.88e+09. In the year 2008, what is the difference between the Value added (constant 2005 US$) of Bermuda and Value added (constant 2005 US$) of Turkey?
Provide a succinct answer. -1.37e+11. In the year 2008, what is the difference between the Value added (constant 2005 US$) of Jamaica and Value added (constant 2005 US$) of Turkey?
Offer a terse response. -1.35e+11. In the year 2009, what is the difference between the Value added (constant 2005 US$) of Belgium and Value added (constant 2005 US$) of Bermuda?
Provide a short and direct response. 8.73e+1. In the year 2009, what is the difference between the Value added (constant 2005 US$) in Belgium and Value added (constant 2005 US$) in Jamaica?
Your answer should be very brief. 8.56e+1. In the year 2009, what is the difference between the Value added (constant 2005 US$) in Belgium and Value added (constant 2005 US$) in Turkey?
Your answer should be compact. -3.76e+1. In the year 2009, what is the difference between the Value added (constant 2005 US$) of Bermuda and Value added (constant 2005 US$) of Jamaica?
Provide a short and direct response. -1.62e+09. In the year 2009, what is the difference between the Value added (constant 2005 US$) of Bermuda and Value added (constant 2005 US$) of Turkey?
Your response must be concise. -1.25e+11. In the year 2009, what is the difference between the Value added (constant 2005 US$) of Jamaica and Value added (constant 2005 US$) of Turkey?
Your answer should be very brief. -1.23e+11. In the year 2010, what is the difference between the Value added (constant 2005 US$) of Belgium and Value added (constant 2005 US$) of Bermuda?
Your response must be concise. 9.14e+1. In the year 2010, what is the difference between the Value added (constant 2005 US$) in Belgium and Value added (constant 2005 US$) in Jamaica?
Offer a terse response. 8.98e+1. In the year 2010, what is the difference between the Value added (constant 2005 US$) in Belgium and Value added (constant 2005 US$) in Turkey?
Offer a very short reply. -5.09e+1. In the year 2010, what is the difference between the Value added (constant 2005 US$) of Bermuda and Value added (constant 2005 US$) of Jamaica?
Your answer should be compact. -1.61e+09. In the year 2010, what is the difference between the Value added (constant 2005 US$) of Bermuda and Value added (constant 2005 US$) of Turkey?
Your answer should be very brief. -1.42e+11. In the year 2010, what is the difference between the Value added (constant 2005 US$) in Jamaica and Value added (constant 2005 US$) in Turkey?
Ensure brevity in your answer.  -1.41e+11. In the year 2011, what is the difference between the Value added (constant 2005 US$) in Belgium and Value added (constant 2005 US$) in Bermuda?
Ensure brevity in your answer.  9.37e+1. In the year 2011, what is the difference between the Value added (constant 2005 US$) in Belgium and Value added (constant 2005 US$) in Jamaica?
Ensure brevity in your answer.  9.20e+1. In the year 2011, what is the difference between the Value added (constant 2005 US$) of Belgium and Value added (constant 2005 US$) of Turkey?
Your answer should be compact. -6.29e+1. In the year 2011, what is the difference between the Value added (constant 2005 US$) in Bermuda and Value added (constant 2005 US$) in Jamaica?
Provide a short and direct response. -1.67e+09. In the year 2011, what is the difference between the Value added (constant 2005 US$) of Bermuda and Value added (constant 2005 US$) of Turkey?
Keep it short and to the point. -1.57e+11. In the year 2011, what is the difference between the Value added (constant 2005 US$) of Jamaica and Value added (constant 2005 US$) of Turkey?
Make the answer very short. -1.55e+11. What is the ratio of the Value added (constant 2005 US$) in Belgium in 2005 to that in 2006?
Ensure brevity in your answer.  0.97. What is the ratio of the Value added (constant 2005 US$) of Bermuda in 2005 to that in 2006?
Your answer should be compact. 1.03. What is the ratio of the Value added (constant 2005 US$) in Jamaica in 2005 to that in 2006?
Your answer should be very brief. 1.01. What is the ratio of the Value added (constant 2005 US$) of Turkey in 2005 to that in 2006?
Give a very brief answer. 0.91. What is the ratio of the Value added (constant 2005 US$) in Belgium in 2005 to that in 2007?
Your response must be concise. 0.93. What is the ratio of the Value added (constant 2005 US$) in Bermuda in 2005 to that in 2007?
Offer a very short reply. 1.03. What is the ratio of the Value added (constant 2005 US$) in Turkey in 2005 to that in 2007?
Your answer should be very brief. 0.86. What is the ratio of the Value added (constant 2005 US$) in Belgium in 2005 to that in 2008?
Make the answer very short. 0.93. What is the ratio of the Value added (constant 2005 US$) of Bermuda in 2005 to that in 2008?
Give a very brief answer. 0.98. What is the ratio of the Value added (constant 2005 US$) of Jamaica in 2005 to that in 2008?
Your answer should be very brief. 1.03. What is the ratio of the Value added (constant 2005 US$) of Turkey in 2005 to that in 2008?
Your answer should be very brief. 0.87. What is the ratio of the Value added (constant 2005 US$) in Bermuda in 2005 to that in 2009?
Offer a terse response. 1.08. What is the ratio of the Value added (constant 2005 US$) in Jamaica in 2005 to that in 2009?
Offer a very short reply. 1.18. What is the ratio of the Value added (constant 2005 US$) of Turkey in 2005 to that in 2009?
Your response must be concise. 0.95. What is the ratio of the Value added (constant 2005 US$) in Belgium in 2005 to that in 2010?
Provide a short and direct response. 0.95. What is the ratio of the Value added (constant 2005 US$) in Bermuda in 2005 to that in 2010?
Your answer should be compact. 1.22. What is the ratio of the Value added (constant 2005 US$) of Jamaica in 2005 to that in 2010?
Ensure brevity in your answer.  1.22. What is the ratio of the Value added (constant 2005 US$) of Turkey in 2005 to that in 2010?
Your response must be concise. 0.83. What is the ratio of the Value added (constant 2005 US$) in Belgium in 2005 to that in 2011?
Ensure brevity in your answer.  0.92. What is the ratio of the Value added (constant 2005 US$) in Bermuda in 2005 to that in 2011?
Your answer should be compact. 1.24. What is the ratio of the Value added (constant 2005 US$) of Jamaica in 2005 to that in 2011?
Give a very brief answer. 1.19. What is the ratio of the Value added (constant 2005 US$) in Turkey in 2005 to that in 2011?
Give a very brief answer. 0.76. What is the ratio of the Value added (constant 2005 US$) of Belgium in 2006 to that in 2007?
Provide a short and direct response. 0.96. What is the ratio of the Value added (constant 2005 US$) in Jamaica in 2006 to that in 2007?
Provide a short and direct response. 0.99. What is the ratio of the Value added (constant 2005 US$) of Turkey in 2006 to that in 2007?
Provide a succinct answer. 0.95. What is the ratio of the Value added (constant 2005 US$) of Belgium in 2006 to that in 2008?
Your answer should be very brief. 0.96. What is the ratio of the Value added (constant 2005 US$) of Bermuda in 2006 to that in 2008?
Ensure brevity in your answer.  0.95. What is the ratio of the Value added (constant 2005 US$) of Jamaica in 2006 to that in 2008?
Keep it short and to the point. 1.02. What is the ratio of the Value added (constant 2005 US$) of Turkey in 2006 to that in 2008?
Ensure brevity in your answer.  0.96. What is the ratio of the Value added (constant 2005 US$) of Bermuda in 2006 to that in 2009?
Offer a terse response. 1.05. What is the ratio of the Value added (constant 2005 US$) in Jamaica in 2006 to that in 2009?
Your response must be concise. 1.17. What is the ratio of the Value added (constant 2005 US$) in Turkey in 2006 to that in 2009?
Make the answer very short. 1.05. What is the ratio of the Value added (constant 2005 US$) in Belgium in 2006 to that in 2010?
Your answer should be compact. 0.98. What is the ratio of the Value added (constant 2005 US$) in Bermuda in 2006 to that in 2010?
Give a very brief answer. 1.18. What is the ratio of the Value added (constant 2005 US$) of Jamaica in 2006 to that in 2010?
Your answer should be very brief. 1.21. What is the ratio of the Value added (constant 2005 US$) of Turkey in 2006 to that in 2010?
Your response must be concise. 0.92. What is the ratio of the Value added (constant 2005 US$) in Bermuda in 2006 to that in 2011?
Your answer should be compact. 1.21. What is the ratio of the Value added (constant 2005 US$) of Jamaica in 2006 to that in 2011?
Ensure brevity in your answer.  1.17. What is the ratio of the Value added (constant 2005 US$) in Turkey in 2006 to that in 2011?
Your response must be concise. 0.84. What is the ratio of the Value added (constant 2005 US$) in Belgium in 2007 to that in 2008?
Offer a terse response. 1.01. What is the ratio of the Value added (constant 2005 US$) of Bermuda in 2007 to that in 2008?
Offer a very short reply. 0.95. What is the ratio of the Value added (constant 2005 US$) in Jamaica in 2007 to that in 2008?
Your answer should be very brief. 1.03. What is the ratio of the Value added (constant 2005 US$) of Turkey in 2007 to that in 2008?
Your response must be concise. 1.01. What is the ratio of the Value added (constant 2005 US$) in Belgium in 2007 to that in 2009?
Keep it short and to the point. 1.07. What is the ratio of the Value added (constant 2005 US$) of Bermuda in 2007 to that in 2009?
Ensure brevity in your answer.  1.05. What is the ratio of the Value added (constant 2005 US$) in Jamaica in 2007 to that in 2009?
Keep it short and to the point. 1.19. What is the ratio of the Value added (constant 2005 US$) of Turkey in 2007 to that in 2009?
Keep it short and to the point. 1.11. What is the ratio of the Value added (constant 2005 US$) of Belgium in 2007 to that in 2010?
Ensure brevity in your answer.  1.02. What is the ratio of the Value added (constant 2005 US$) in Bermuda in 2007 to that in 2010?
Provide a short and direct response. 1.19. What is the ratio of the Value added (constant 2005 US$) of Jamaica in 2007 to that in 2010?
Keep it short and to the point. 1.23. What is the ratio of the Value added (constant 2005 US$) in Turkey in 2007 to that in 2010?
Ensure brevity in your answer.  0.97. What is the ratio of the Value added (constant 2005 US$) of Belgium in 2007 to that in 2011?
Provide a short and direct response. 1. What is the ratio of the Value added (constant 2005 US$) of Bermuda in 2007 to that in 2011?
Make the answer very short. 1.21. What is the ratio of the Value added (constant 2005 US$) of Jamaica in 2007 to that in 2011?
Ensure brevity in your answer.  1.19. What is the ratio of the Value added (constant 2005 US$) in Turkey in 2007 to that in 2011?
Keep it short and to the point. 0.88. What is the ratio of the Value added (constant 2005 US$) of Belgium in 2008 to that in 2009?
Offer a very short reply. 1.06. What is the ratio of the Value added (constant 2005 US$) of Bermuda in 2008 to that in 2009?
Ensure brevity in your answer.  1.1. What is the ratio of the Value added (constant 2005 US$) of Jamaica in 2008 to that in 2009?
Offer a terse response. 1.15. What is the ratio of the Value added (constant 2005 US$) of Turkey in 2008 to that in 2009?
Your answer should be compact. 1.09. What is the ratio of the Value added (constant 2005 US$) in Belgium in 2008 to that in 2010?
Your response must be concise. 1.01. What is the ratio of the Value added (constant 2005 US$) in Bermuda in 2008 to that in 2010?
Make the answer very short. 1.25. What is the ratio of the Value added (constant 2005 US$) of Jamaica in 2008 to that in 2010?
Offer a terse response. 1.19. What is the ratio of the Value added (constant 2005 US$) of Turkey in 2008 to that in 2010?
Your answer should be compact. 0.96. What is the ratio of the Value added (constant 2005 US$) of Belgium in 2008 to that in 2011?
Give a very brief answer. 0.99. What is the ratio of the Value added (constant 2005 US$) of Bermuda in 2008 to that in 2011?
Ensure brevity in your answer.  1.27. What is the ratio of the Value added (constant 2005 US$) of Jamaica in 2008 to that in 2011?
Your response must be concise. 1.15. What is the ratio of the Value added (constant 2005 US$) of Turkey in 2008 to that in 2011?
Make the answer very short. 0.87. What is the ratio of the Value added (constant 2005 US$) of Belgium in 2009 to that in 2010?
Offer a very short reply. 0.96. What is the ratio of the Value added (constant 2005 US$) in Bermuda in 2009 to that in 2010?
Your answer should be very brief. 1.13. What is the ratio of the Value added (constant 2005 US$) in Jamaica in 2009 to that in 2010?
Keep it short and to the point. 1.03. What is the ratio of the Value added (constant 2005 US$) of Turkey in 2009 to that in 2010?
Give a very brief answer. 0.88. What is the ratio of the Value added (constant 2005 US$) in Belgium in 2009 to that in 2011?
Your answer should be compact. 0.93. What is the ratio of the Value added (constant 2005 US$) of Bermuda in 2009 to that in 2011?
Ensure brevity in your answer.  1.15. What is the ratio of the Value added (constant 2005 US$) in Jamaica in 2009 to that in 2011?
Offer a terse response. 1. What is the ratio of the Value added (constant 2005 US$) in Turkey in 2009 to that in 2011?
Your answer should be compact. 0.8. What is the ratio of the Value added (constant 2005 US$) of Belgium in 2010 to that in 2011?
Give a very brief answer. 0.98. What is the ratio of the Value added (constant 2005 US$) in Bermuda in 2010 to that in 2011?
Make the answer very short. 1.02. What is the ratio of the Value added (constant 2005 US$) of Jamaica in 2010 to that in 2011?
Ensure brevity in your answer.  0.97. What is the ratio of the Value added (constant 2005 US$) of Turkey in 2010 to that in 2011?
Your answer should be very brief. 0.91. What is the difference between the highest and the second highest Value added (constant 2005 US$) of Belgium?
Your answer should be compact. 4.31e+08. What is the difference between the highest and the second highest Value added (constant 2005 US$) of Bermuda?
Provide a short and direct response. 1.13e+07. What is the difference between the highest and the second highest Value added (constant 2005 US$) of Jamaica?
Provide a succinct answer. 4.26e+06. What is the difference between the highest and the second highest Value added (constant 2005 US$) in Turkey?
Your response must be concise. 1.43e+1. What is the difference between the highest and the lowest Value added (constant 2005 US$) in Belgium?
Give a very brief answer. 7.14e+09. What is the difference between the highest and the lowest Value added (constant 2005 US$) in Bermuda?
Your answer should be very brief. 1.06e+08. What is the difference between the highest and the lowest Value added (constant 2005 US$) of Jamaica?
Offer a very short reply. 4.54e+08. What is the difference between the highest and the lowest Value added (constant 2005 US$) of Turkey?
Offer a terse response. 3.79e+1. 